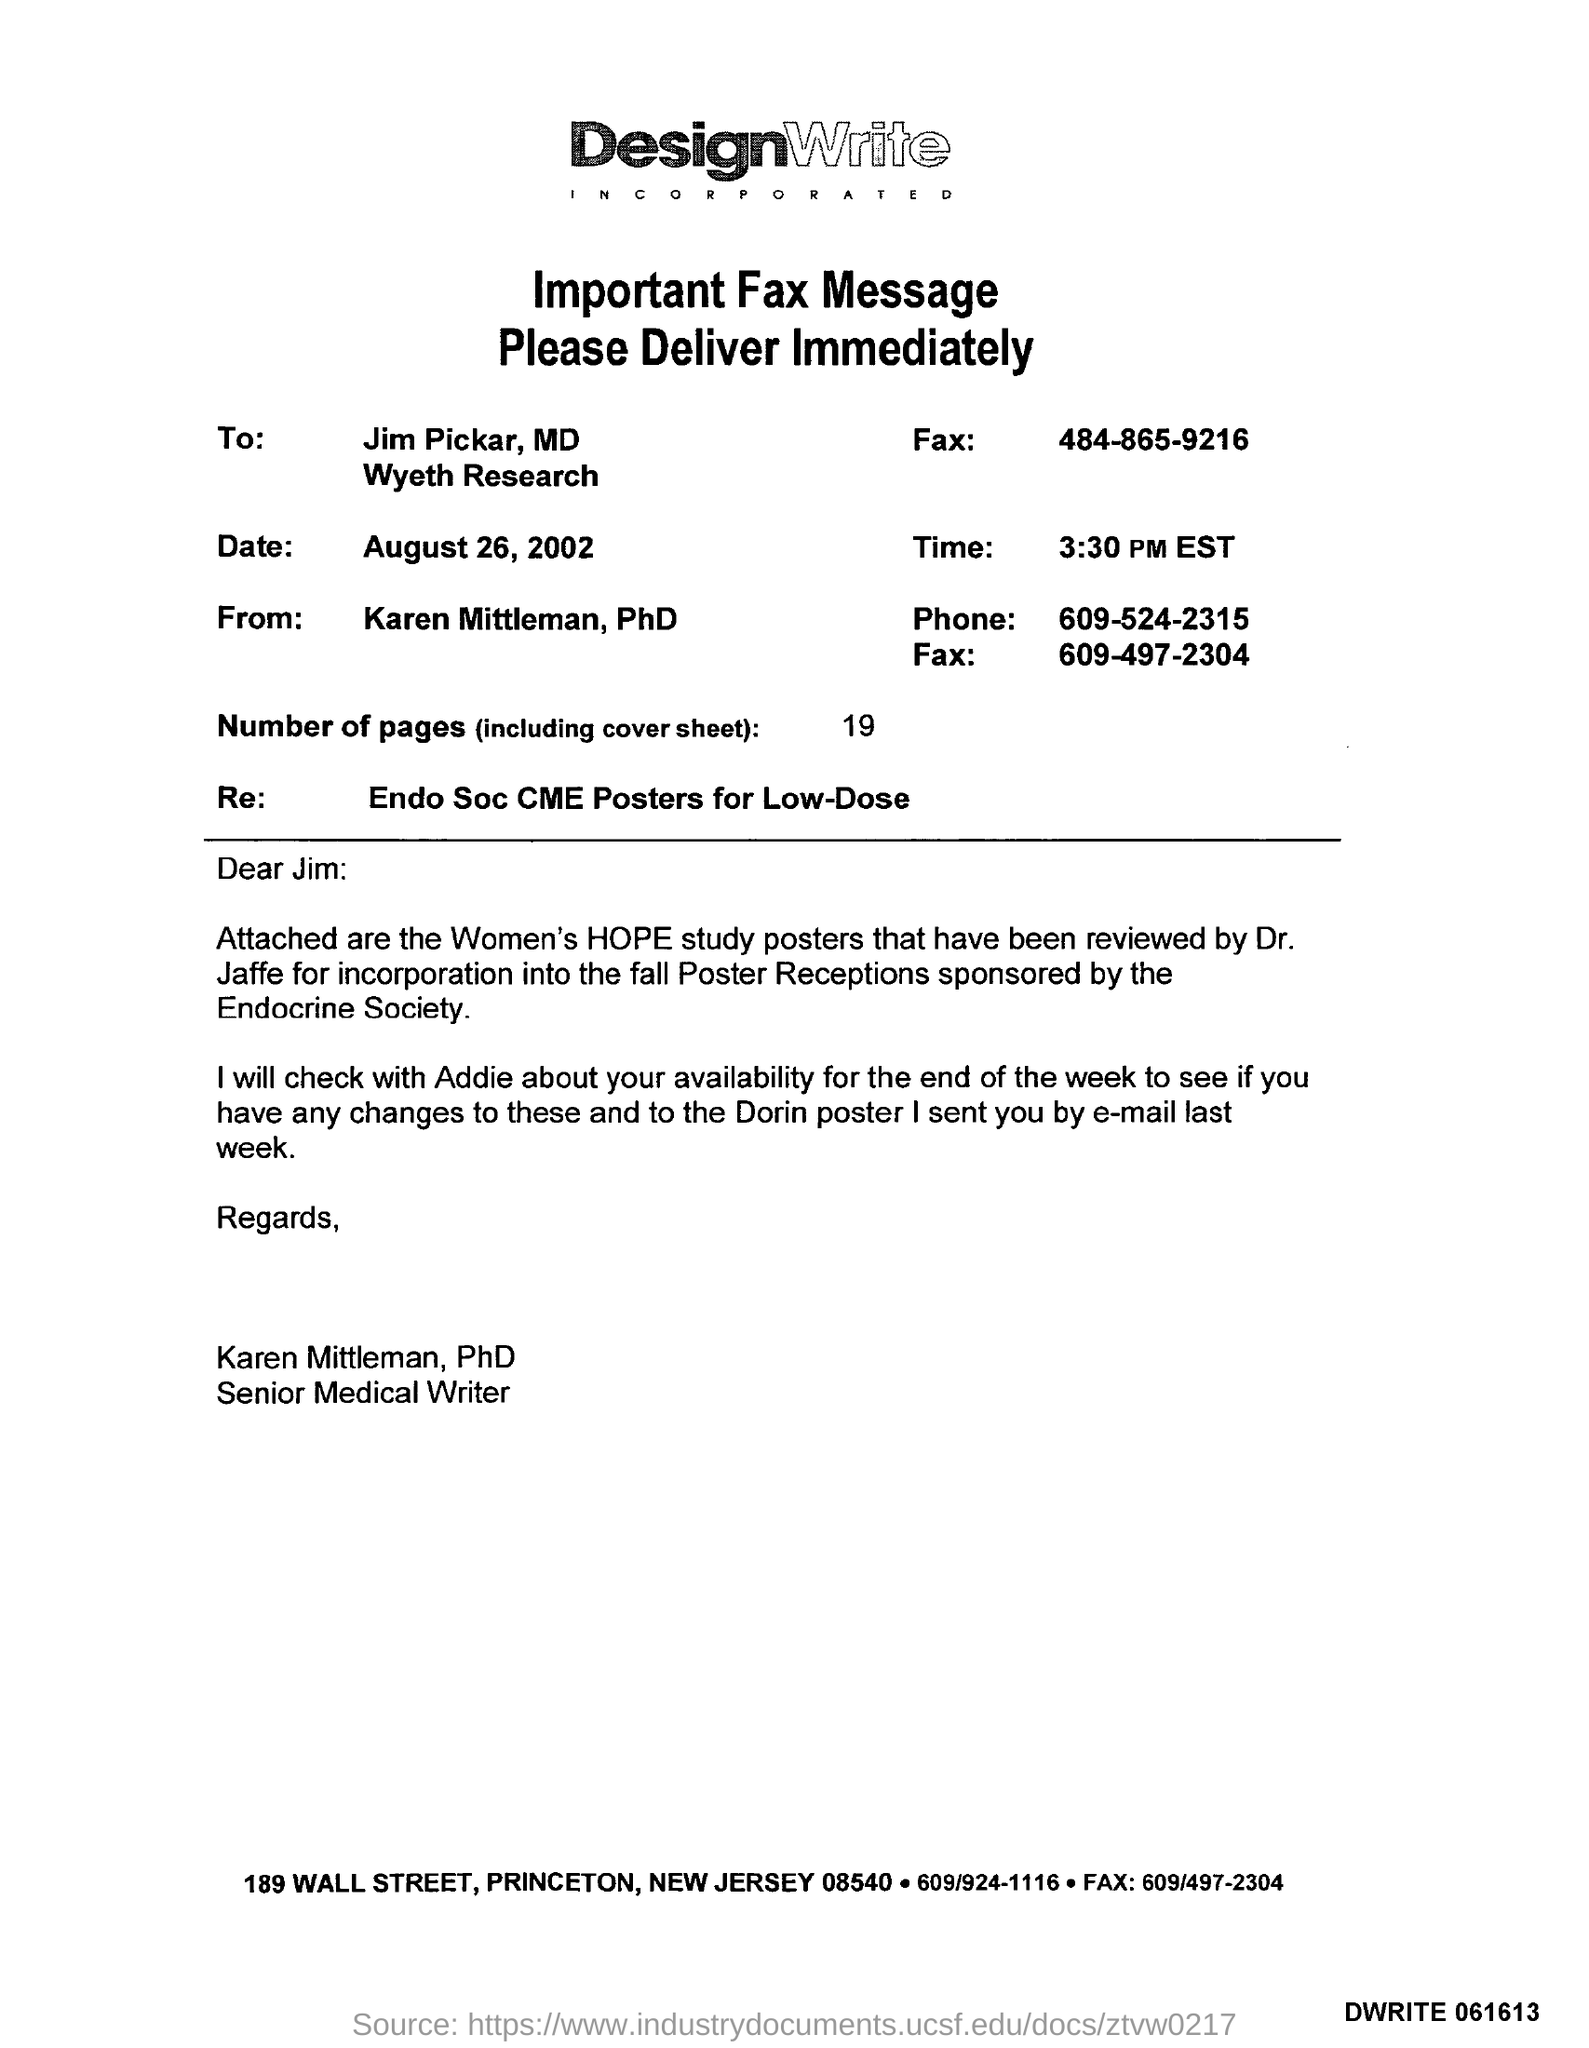Draw attention to some important aspects in this diagram. There were a total of 19 sheets including the cover sheet. The salutation of the letter is "Dear Jim. The attachment referred to in this letter is the Women's HOPE study posters. 